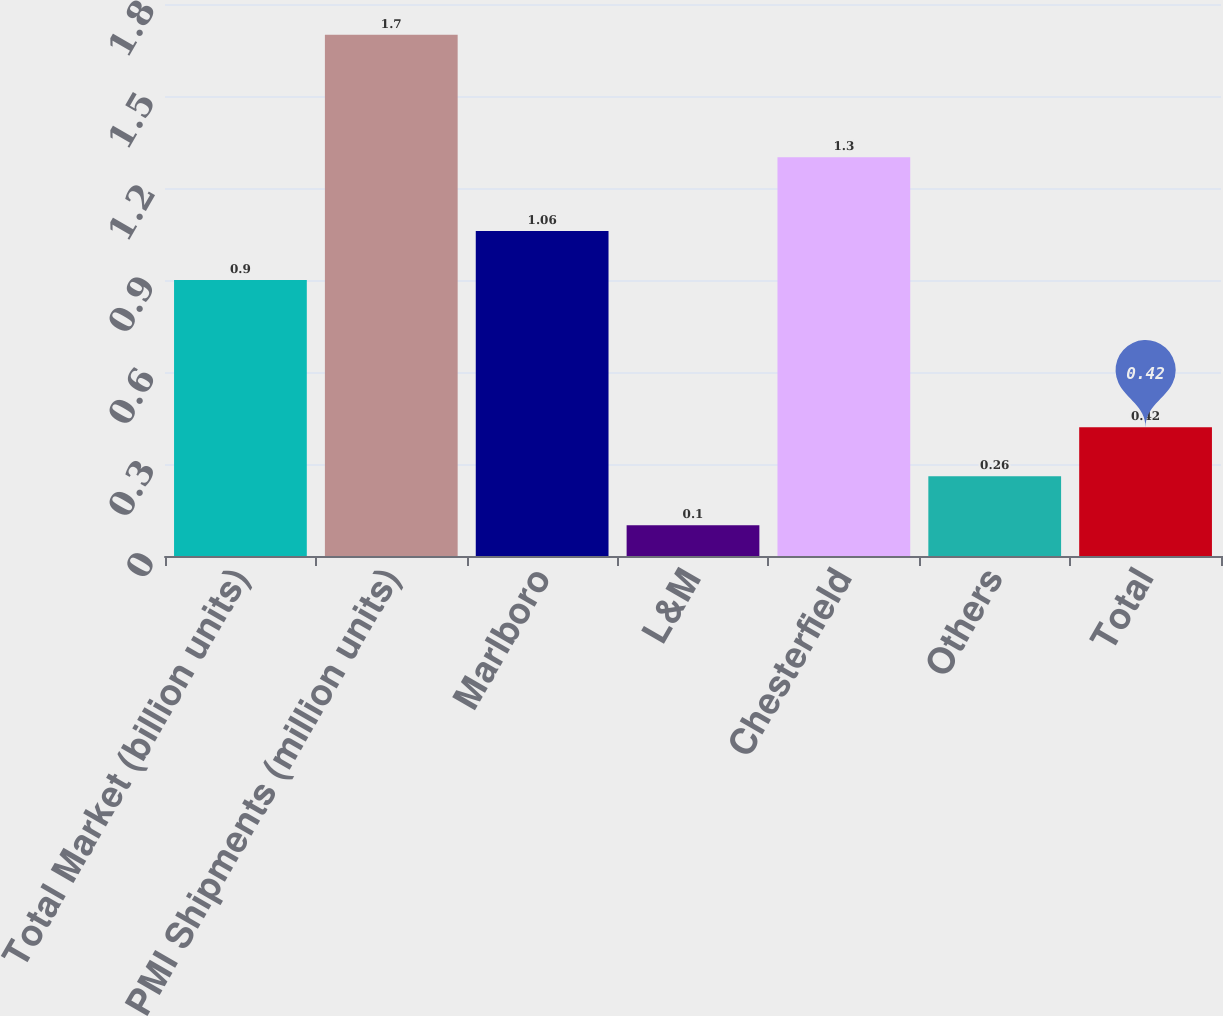<chart> <loc_0><loc_0><loc_500><loc_500><bar_chart><fcel>Total Market (billion units)<fcel>PMI Shipments (million units)<fcel>Marlboro<fcel>L&M<fcel>Chesterfield<fcel>Others<fcel>Total<nl><fcel>0.9<fcel>1.7<fcel>1.06<fcel>0.1<fcel>1.3<fcel>0.26<fcel>0.42<nl></chart> 